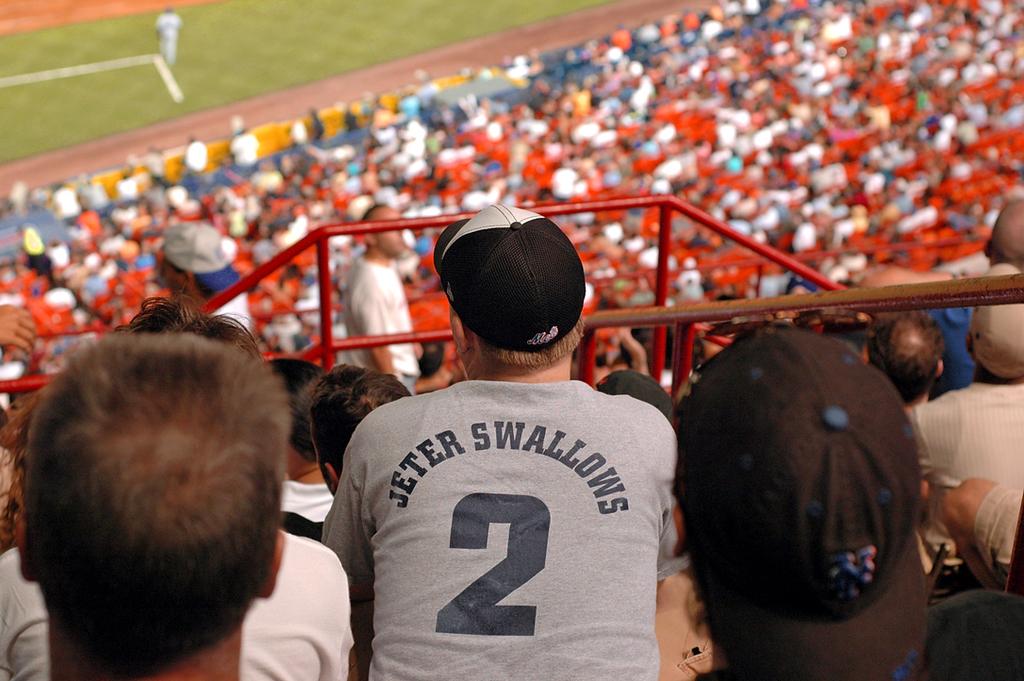Does the player who's number is on this fans shirt care about this disrespect?
Your response must be concise. Unanswerable. 